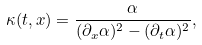Convert formula to latex. <formula><loc_0><loc_0><loc_500><loc_500>\kappa ( t , x ) = \frac { \alpha } { ( \partial _ { x } \alpha ) ^ { 2 } - ( \partial _ { t } \alpha ) ^ { 2 } } ,</formula> 